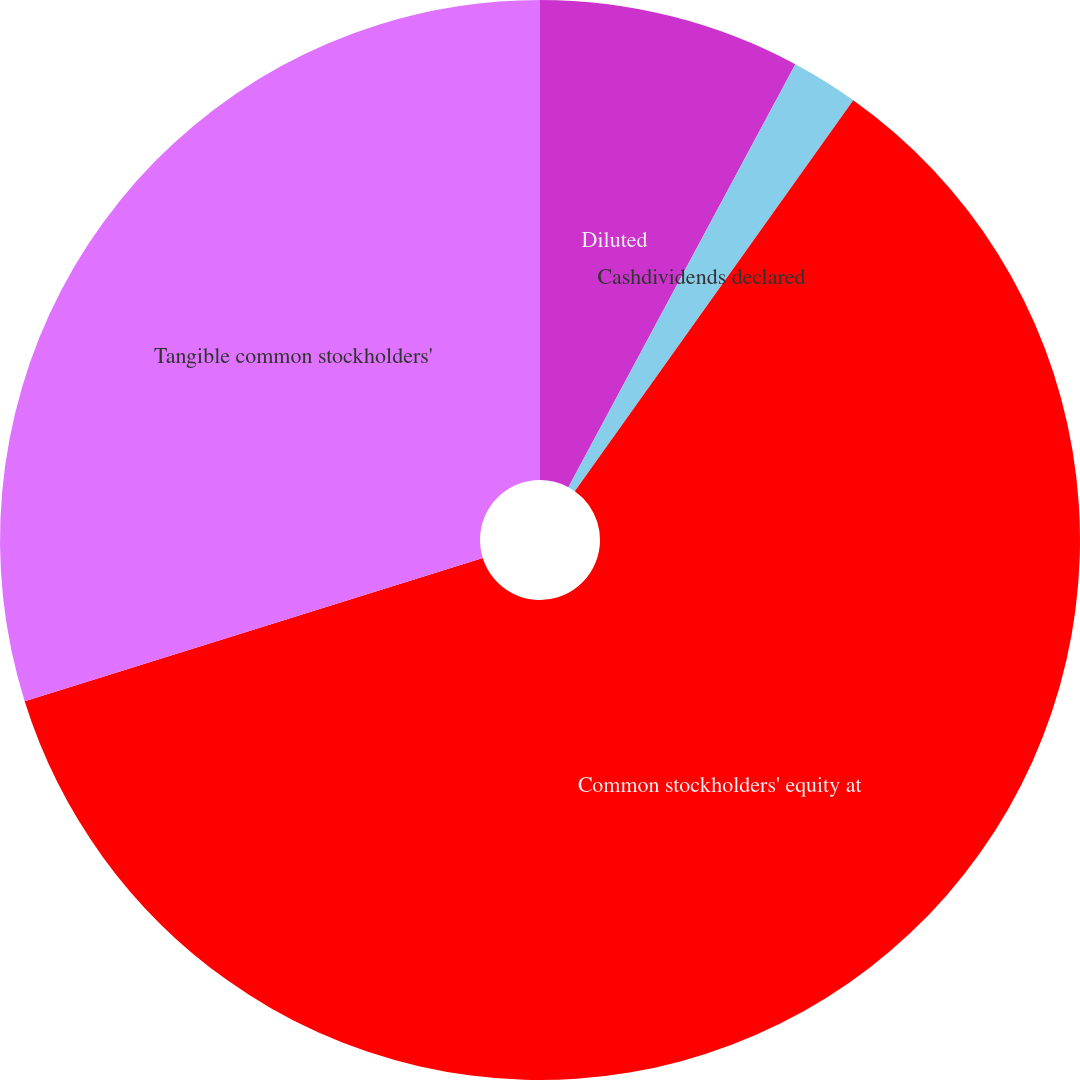Convert chart to OTSL. <chart><loc_0><loc_0><loc_500><loc_500><pie_chart><fcel>Diluted<fcel>Cashdividends declared<fcel>Common stockholders' equity at<fcel>Tangible common stockholders'<nl><fcel>7.84%<fcel>2.01%<fcel>60.32%<fcel>29.83%<nl></chart> 